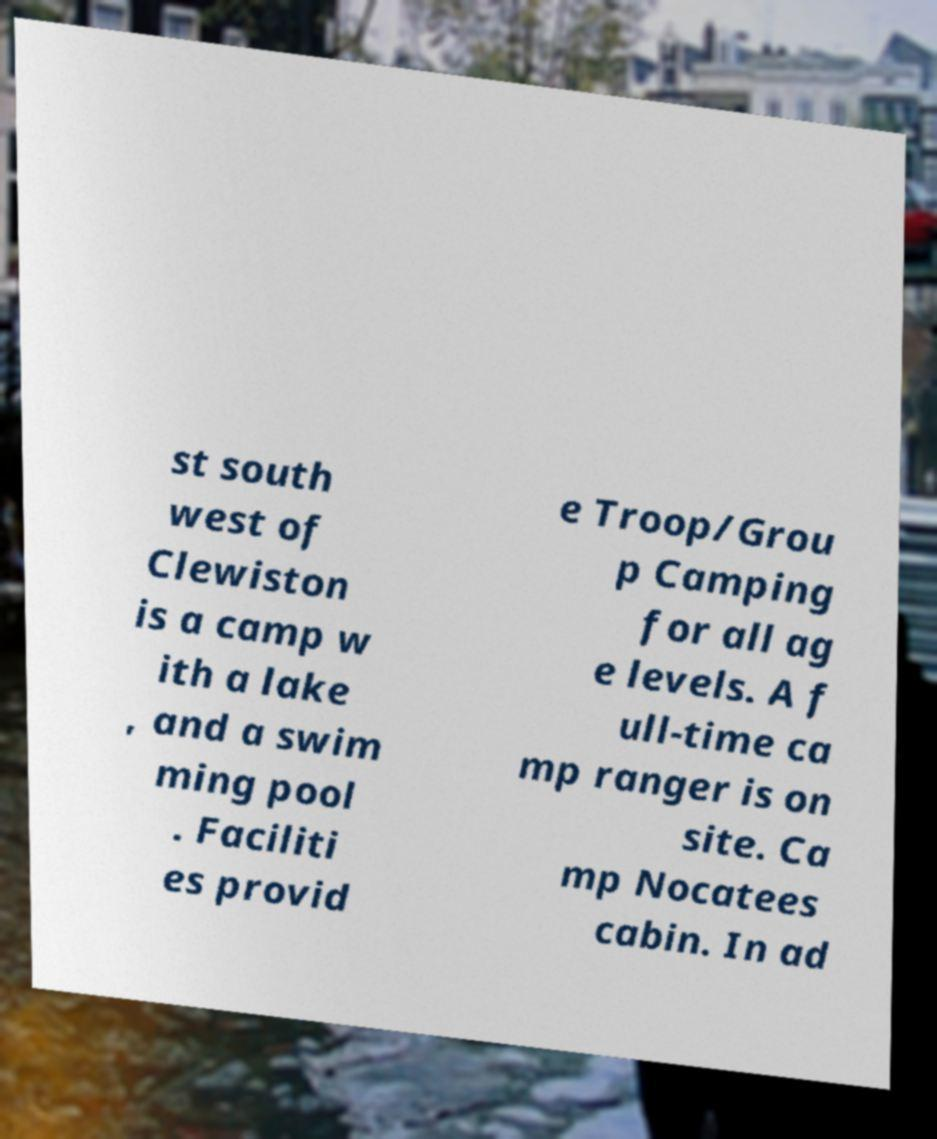Can you accurately transcribe the text from the provided image for me? st south west of Clewiston is a camp w ith a lake , and a swim ming pool . Faciliti es provid e Troop/Grou p Camping for all ag e levels. A f ull-time ca mp ranger is on site. Ca mp Nocatees cabin. In ad 